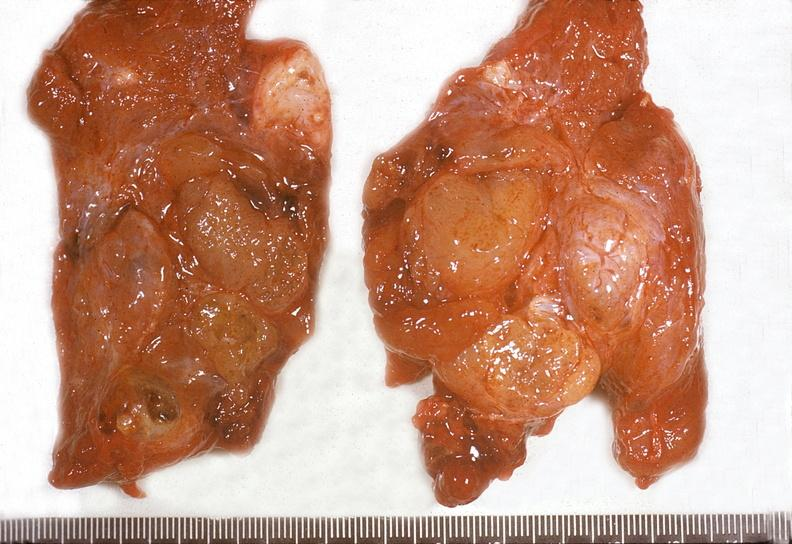s endocrine present?
Answer the question using a single word or phrase. Yes 